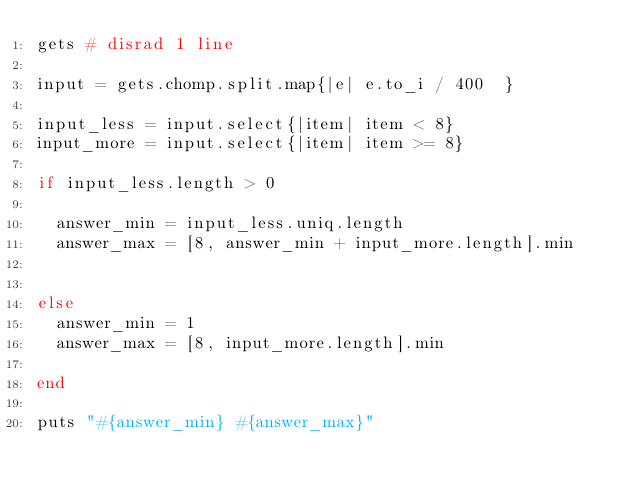<code> <loc_0><loc_0><loc_500><loc_500><_Ruby_>gets # disrad 1 line

input = gets.chomp.split.map{|e| e.to_i / 400  }

input_less = input.select{|item| item < 8}
input_more = input.select{|item| item >= 8}

if input_less.length > 0

  answer_min = input_less.uniq.length
  answer_max = [8, answer_min + input_more.length].min


else
  answer_min = 1
  answer_max = [8, input_more.length].min

end

puts "#{answer_min} #{answer_max}"
</code> 